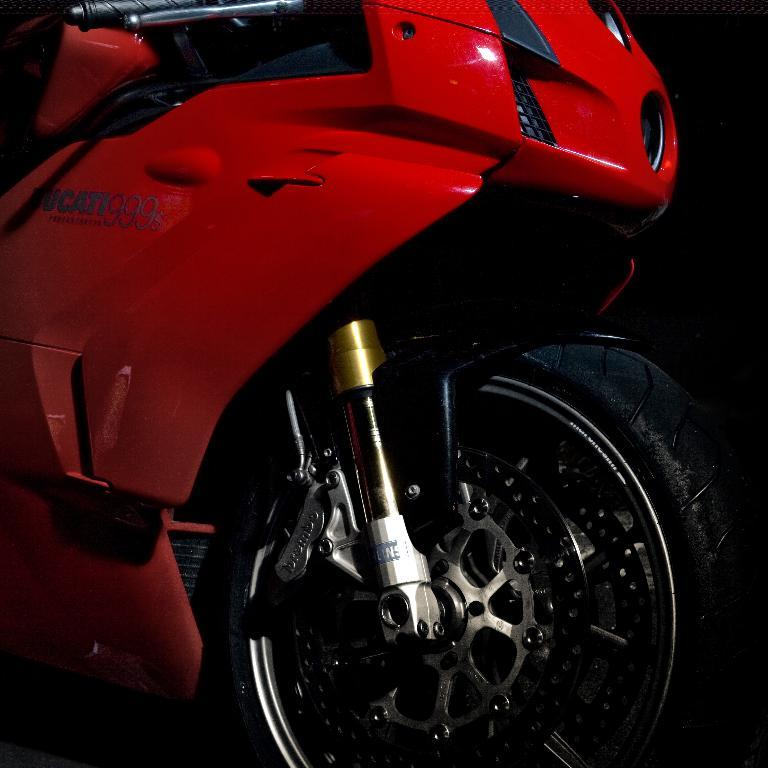What type of vehicle is in the image? There is a red bike in the image. How much of the bike is visible in the image? The bike is truncated or partially visible in the image. What type of authority figure can be seen standing next to the bike in the image? There is no authority figure present in the image; it only features a red bike. 